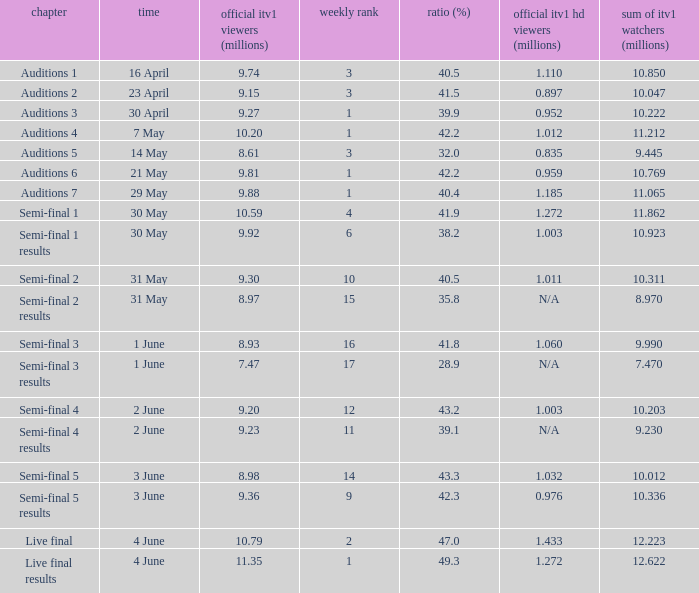What was the official ITV1 rating in millions of the Live Final Results episode? 11.35. Can you give me this table as a dict? {'header': ['chapter', 'time', 'official itv1 viewers (millions)', 'weekly rank', 'ratio (%)', 'official itv1 hd viewers (millions)', 'sum of itv1 watchers (millions)'], 'rows': [['Auditions 1', '16 April', '9.74', '3', '40.5', '1.110', '10.850'], ['Auditions 2', '23 April', '9.15', '3', '41.5', '0.897', '10.047'], ['Auditions 3', '30 April', '9.27', '1', '39.9', '0.952', '10.222'], ['Auditions 4', '7 May', '10.20', '1', '42.2', '1.012', '11.212'], ['Auditions 5', '14 May', '8.61', '3', '32.0', '0.835', '9.445'], ['Auditions 6', '21 May', '9.81', '1', '42.2', '0.959', '10.769'], ['Auditions 7', '29 May', '9.88', '1', '40.4', '1.185', '11.065'], ['Semi-final 1', '30 May', '10.59', '4', '41.9', '1.272', '11.862'], ['Semi-final 1 results', '30 May', '9.92', '6', '38.2', '1.003', '10.923'], ['Semi-final 2', '31 May', '9.30', '10', '40.5', '1.011', '10.311'], ['Semi-final 2 results', '31 May', '8.97', '15', '35.8', 'N/A', '8.970'], ['Semi-final 3', '1 June', '8.93', '16', '41.8', '1.060', '9.990'], ['Semi-final 3 results', '1 June', '7.47', '17', '28.9', 'N/A', '7.470'], ['Semi-final 4', '2 June', '9.20', '12', '43.2', '1.003', '10.203'], ['Semi-final 4 results', '2 June', '9.23', '11', '39.1', 'N/A', '9.230'], ['Semi-final 5', '3 June', '8.98', '14', '43.3', '1.032', '10.012'], ['Semi-final 5 results', '3 June', '9.36', '9', '42.3', '0.976', '10.336'], ['Live final', '4 June', '10.79', '2', '47.0', '1.433', '12.223'], ['Live final results', '4 June', '11.35', '1', '49.3', '1.272', '12.622']]} 